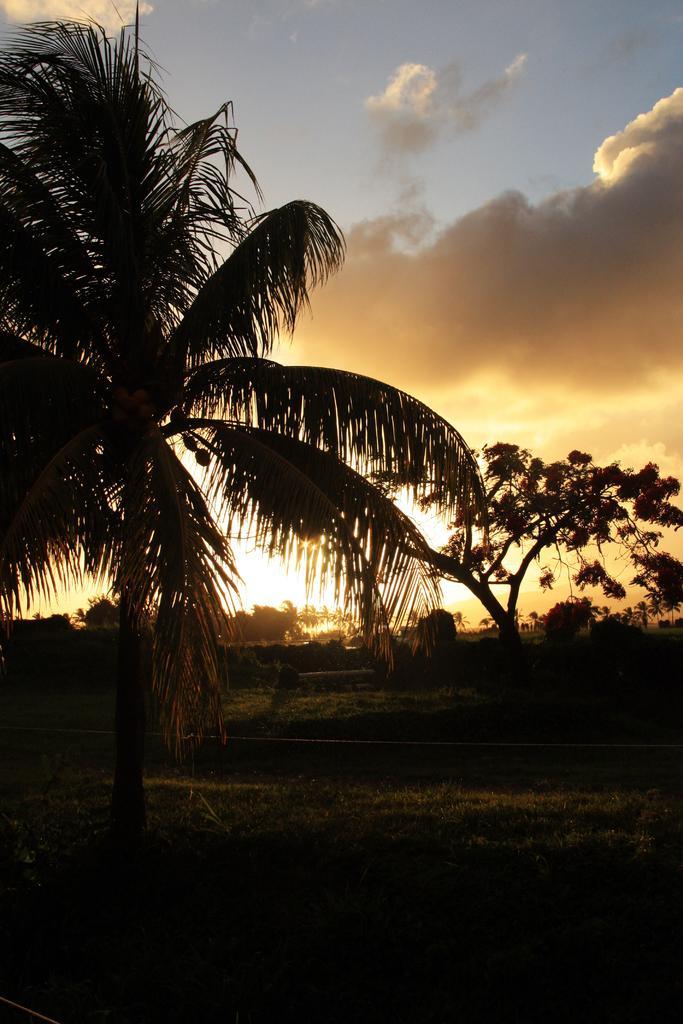Can you describe this image briefly? In this picture there are trees. At the bottom there is grass. At the top there is sky and there are clouds. 